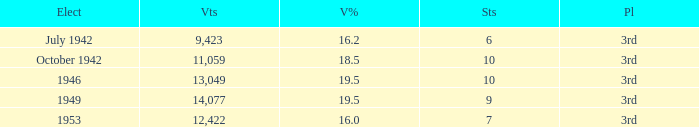Name the sum of votes % more than 19.5 None. 